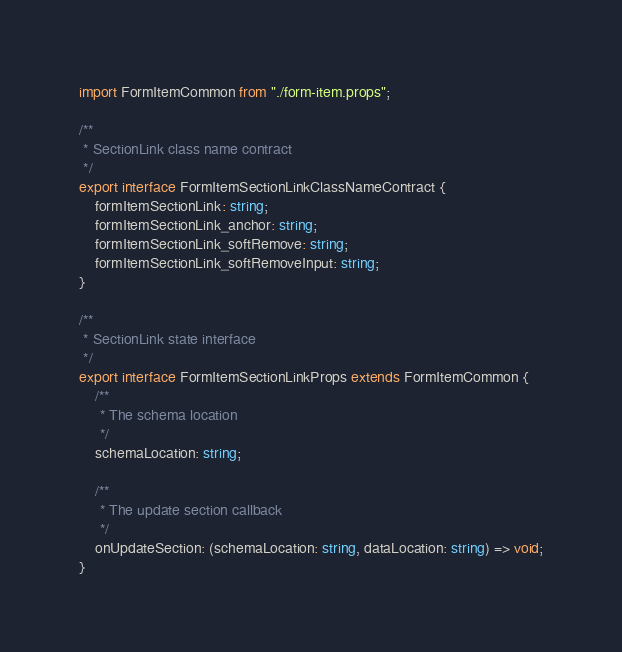<code> <loc_0><loc_0><loc_500><loc_500><_TypeScript_>import FormItemCommon from "./form-item.props";

/**
 * SectionLink class name contract
 */
export interface FormItemSectionLinkClassNameContract {
    formItemSectionLink: string;
    formItemSectionLink_anchor: string;
    formItemSectionLink_softRemove: string;
    formItemSectionLink_softRemoveInput: string;
}

/**
 * SectionLink state interface
 */
export interface FormItemSectionLinkProps extends FormItemCommon {
    /**
     * The schema location
     */
    schemaLocation: string;

    /**
     * The update section callback
     */
    onUpdateSection: (schemaLocation: string, dataLocation: string) => void;
}
</code> 